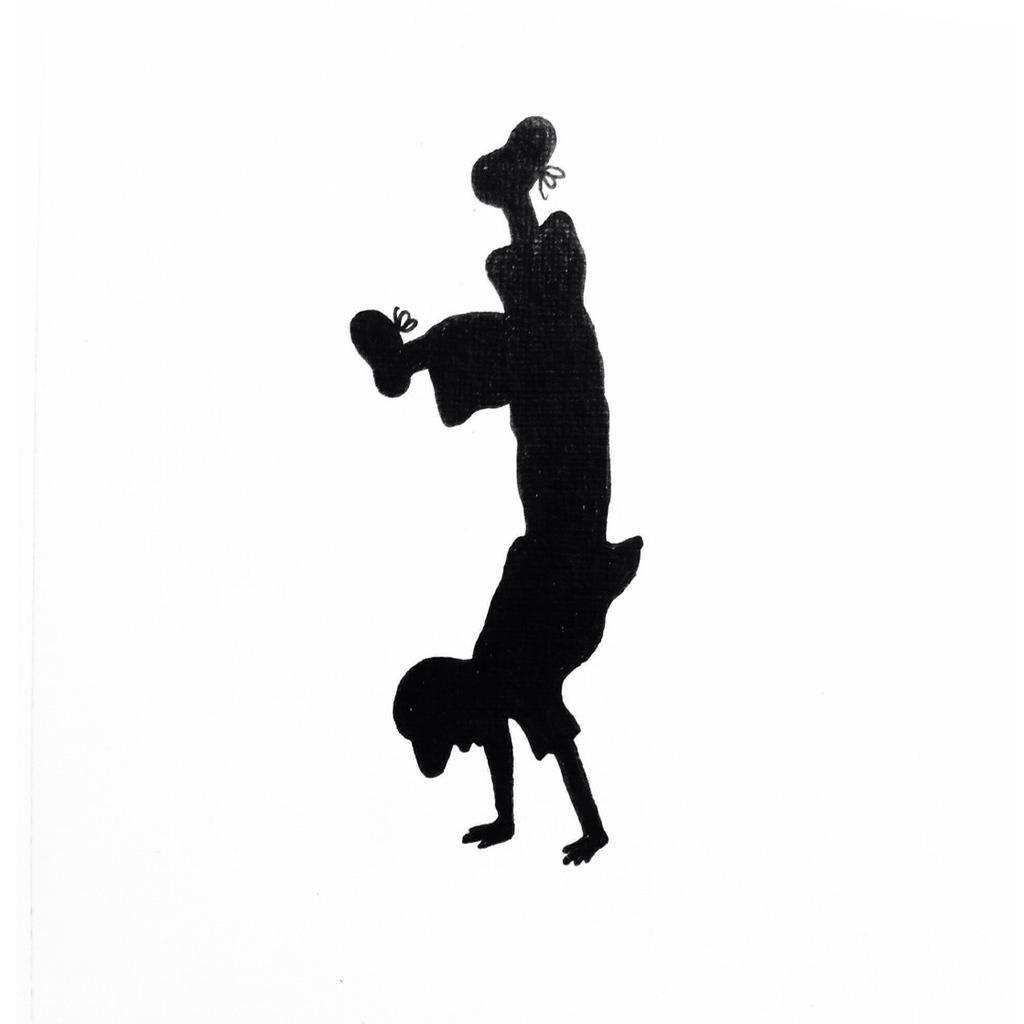What is the main subject of the image? There is a boy in the image. How is the boy positioned in the image? The boy is in an upside-down position. What type of band is playing in the middle of the image? There is no band present in the image; it only features a boy in an upside-down position. 